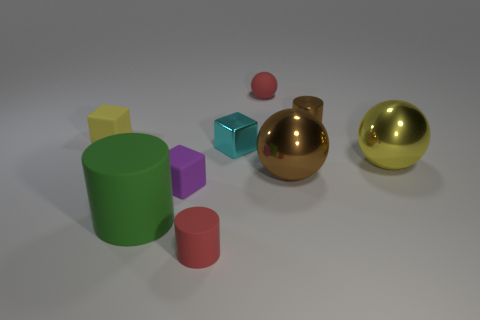Do the tiny rubber cylinder and the small ball have the same color?
Provide a short and direct response. Yes. Are there fewer tiny metallic cylinders than cubes?
Your response must be concise. Yes. What number of purple blocks have the same size as the red matte ball?
Give a very brief answer. 1. What shape is the small matte object that is the same color as the small matte sphere?
Your answer should be very brief. Cylinder. What is the material of the tiny brown cylinder?
Your answer should be very brief. Metal. What is the size of the brown thing that is in front of the small cyan metal thing?
Your answer should be very brief. Large. What number of large yellow things are the same shape as the small purple thing?
Provide a short and direct response. 0. There is a small yellow object that is the same material as the large green cylinder; what is its shape?
Keep it short and to the point. Cube. What number of green things are either metal things or big spheres?
Ensure brevity in your answer.  0. There is a green cylinder; are there any small purple matte blocks on the right side of it?
Your answer should be compact. Yes. 